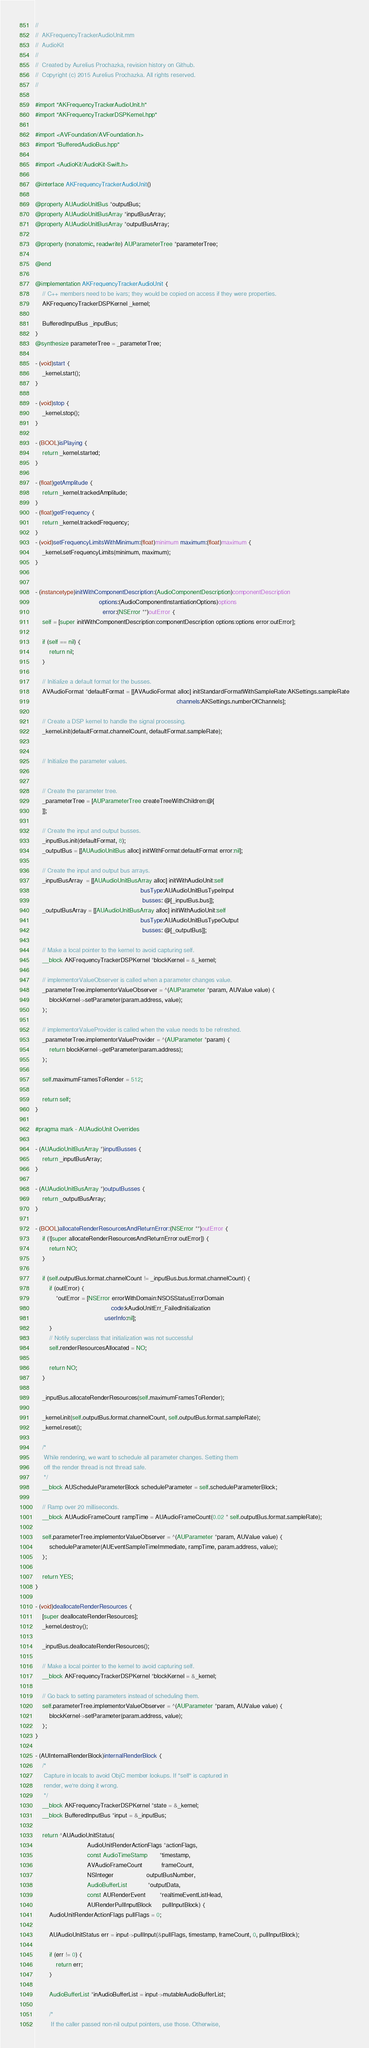<code> <loc_0><loc_0><loc_500><loc_500><_ObjectiveC_>//
//  AKFrequencyTrackerAudioUnit.mm
//  AudioKit
//
//  Created by Aurelius Prochazka, revision history on Github.
//  Copyright (c) 2015 Aurelius Prochazka. All rights reserved.
//

#import "AKFrequencyTrackerAudioUnit.h"
#import "AKFrequencyTrackerDSPKernel.hpp"

#import <AVFoundation/AVFoundation.h>
#import "BufferedAudioBus.hpp"

#import <AudioKit/AudioKit-Swift.h>

@interface AKFrequencyTrackerAudioUnit()

@property AUAudioUnitBus *outputBus;
@property AUAudioUnitBusArray *inputBusArray;
@property AUAudioUnitBusArray *outputBusArray;

@property (nonatomic, readwrite) AUParameterTree *parameterTree;

@end

@implementation AKFrequencyTrackerAudioUnit {
    // C++ members need to be ivars; they would be copied on access if they were properties.
    AKFrequencyTrackerDSPKernel _kernel;

    BufferedInputBus _inputBus;
}
@synthesize parameterTree = _parameterTree;

- (void)start {
    _kernel.start();
}

- (void)stop {
    _kernel.stop();
}

- (BOOL)isPlaying {
    return _kernel.started;
}

- (float)getAmplitude {
    return _kernel.trackedAmplitude;
}
- (float)getFrequency {
    return _kernel.trackedFrequency;
}
- (void)setFrequencyLimitsWithMinimum:(float)minimum maximum:(float)maximum {
    _kernel.setFrequencyLimits(minimum, maximum);
}


- (instancetype)initWithComponentDescription:(AudioComponentDescription)componentDescription
                                     options:(AudioComponentInstantiationOptions)options
                                       error:(NSError **)outError {
    self = [super initWithComponentDescription:componentDescription options:options error:outError];

    if (self == nil) {
        return nil;
    }

    // Initialize a default format for the busses.
    AVAudioFormat *defaultFormat = [[AVAudioFormat alloc] initStandardFormatWithSampleRate:AKSettings.sampleRate
                                                                                  channels:AKSettings.numberOfChannels];

    // Create a DSP kernel to handle the signal processing.
    _kernel.init(defaultFormat.channelCount, defaultFormat.sampleRate);

    
    // Initialize the parameter values.


    // Create the parameter tree.
    _parameterTree = [AUParameterTree createTreeWithChildren:@[
    ]];

    // Create the input and output busses.
    _inputBus.init(defaultFormat, 8);
    _outputBus = [[AUAudioUnitBus alloc] initWithFormat:defaultFormat error:nil];

    // Create the input and output bus arrays.
    _inputBusArray  = [[AUAudioUnitBusArray alloc] initWithAudioUnit:self
                                                             busType:AUAudioUnitBusTypeInput
                                                              busses: @[_inputBus.bus]];
    _outputBusArray = [[AUAudioUnitBusArray alloc] initWithAudioUnit:self
                                                             busType:AUAudioUnitBusTypeOutput
                                                              busses: @[_outputBus]];

    // Make a local pointer to the kernel to avoid capturing self.
    __block AKFrequencyTrackerDSPKernel *blockKernel = &_kernel;

    // implementorValueObserver is called when a parameter changes value.
    _parameterTree.implementorValueObserver = ^(AUParameter *param, AUValue value) {
        blockKernel->setParameter(param.address, value);
    };

    // implementorValueProvider is called when the value needs to be refreshed.
    _parameterTree.implementorValueProvider = ^(AUParameter *param) {
        return blockKernel->getParameter(param.address);
    };

    self.maximumFramesToRender = 512;

    return self;
}

#pragma mark - AUAudioUnit Overrides

- (AUAudioUnitBusArray *)inputBusses {
    return _inputBusArray;
}

- (AUAudioUnitBusArray *)outputBusses {
    return _outputBusArray;
}

- (BOOL)allocateRenderResourcesAndReturnError:(NSError **)outError {
    if (![super allocateRenderResourcesAndReturnError:outError]) {
        return NO;
    }

    if (self.outputBus.format.channelCount != _inputBus.bus.format.channelCount) {
        if (outError) {
            *outError = [NSError errorWithDomain:NSOSStatusErrorDomain
                                            code:kAudioUnitErr_FailedInitialization
                                        userInfo:nil];
        }
        // Notify superclass that initialization was not successful
        self.renderResourcesAllocated = NO;

        return NO;
    }

    _inputBus.allocateRenderResources(self.maximumFramesToRender);

    _kernel.init(self.outputBus.format.channelCount, self.outputBus.format.sampleRate);
    _kernel.reset();

    /*
     While rendering, we want to schedule all parameter changes. Setting them
     off the render thread is not thread safe.
     */
    __block AUScheduleParameterBlock scheduleParameter = self.scheduleParameterBlock;

    // Ramp over 20 milliseconds.
    __block AUAudioFrameCount rampTime = AUAudioFrameCount(0.02 * self.outputBus.format.sampleRate);

    self.parameterTree.implementorValueObserver = ^(AUParameter *param, AUValue value) {
        scheduleParameter(AUEventSampleTimeImmediate, rampTime, param.address, value);
    };

    return YES;
}

- (void)deallocateRenderResources {
    [super deallocateRenderResources];
    _kernel.destroy();

    _inputBus.deallocateRenderResources();

    // Make a local pointer to the kernel to avoid capturing self.
    __block AKFrequencyTrackerDSPKernel *blockKernel = &_kernel;

    // Go back to setting parameters instead of scheduling them.
    self.parameterTree.implementorValueObserver = ^(AUParameter *param, AUValue value) {
        blockKernel->setParameter(param.address, value);
    };
}

- (AUInternalRenderBlock)internalRenderBlock {
    /*
     Capture in locals to avoid ObjC member lookups. If "self" is captured in
     render, we're doing it wrong.
     */
    __block AKFrequencyTrackerDSPKernel *state = &_kernel;
    __block BufferedInputBus *input = &_inputBus;

    return ^AUAudioUnitStatus(
                              AudioUnitRenderActionFlags *actionFlags,
                              const AudioTimeStamp       *timestamp,
                              AVAudioFrameCount           frameCount,
                              NSInteger                   outputBusNumber,
                              AudioBufferList            *outputData,
                              const AURenderEvent        *realtimeEventListHead,
                              AURenderPullInputBlock      pullInputBlock) {
        AudioUnitRenderActionFlags pullFlags = 0;

        AUAudioUnitStatus err = input->pullInput(&pullFlags, timestamp, frameCount, 0, pullInputBlock);

        if (err != 0) {
            return err;
        }

        AudioBufferList *inAudioBufferList = input->mutableAudioBufferList;

        /*
         If the caller passed non-nil output pointers, use those. Otherwise,</code> 